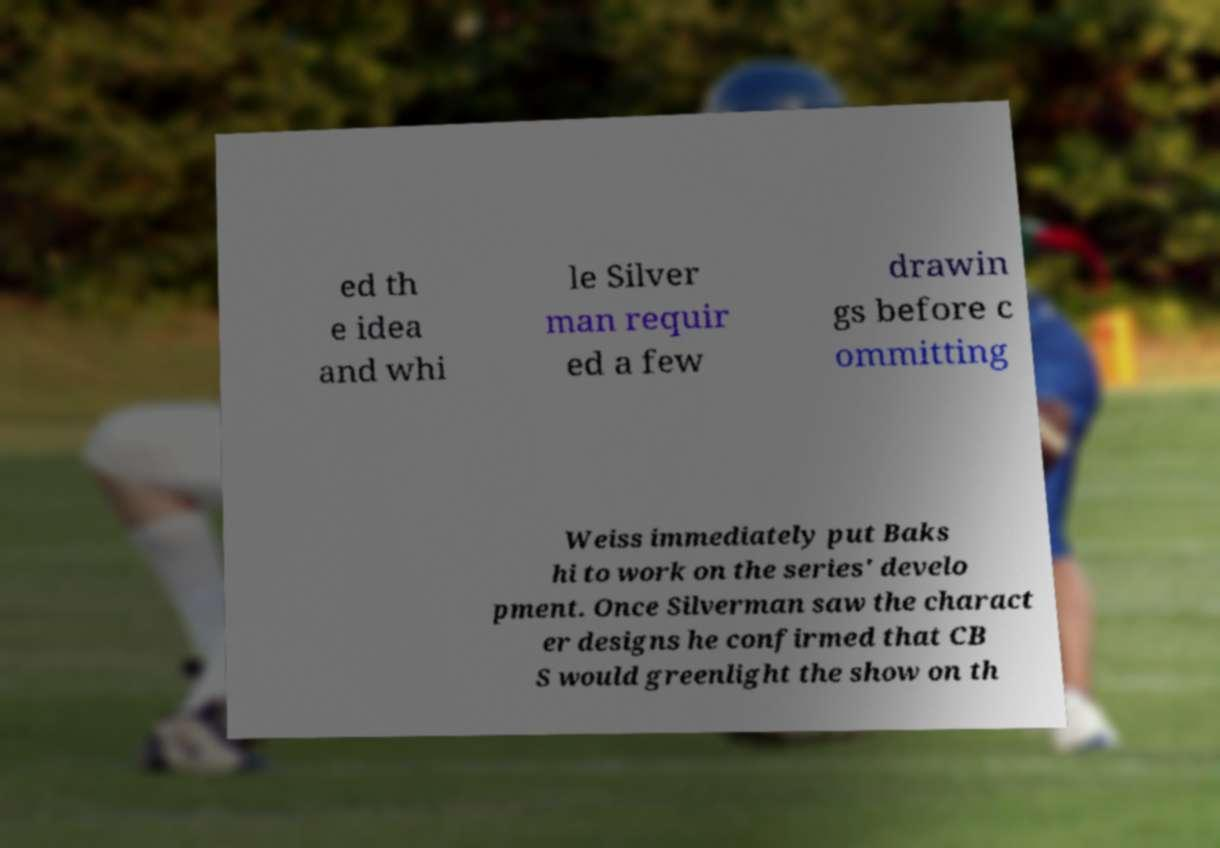Can you accurately transcribe the text from the provided image for me? ed th e idea and whi le Silver man requir ed a few drawin gs before c ommitting Weiss immediately put Baks hi to work on the series' develo pment. Once Silverman saw the charact er designs he confirmed that CB S would greenlight the show on th 